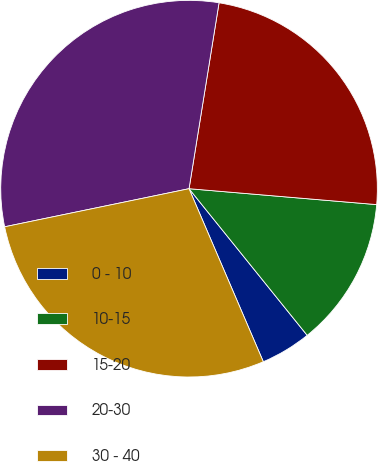Convert chart to OTSL. <chart><loc_0><loc_0><loc_500><loc_500><pie_chart><fcel>0 - 10<fcel>10-15<fcel>15-20<fcel>20-30<fcel>30 - 40<nl><fcel>4.34%<fcel>12.86%<fcel>23.8%<fcel>30.79%<fcel>28.21%<nl></chart> 